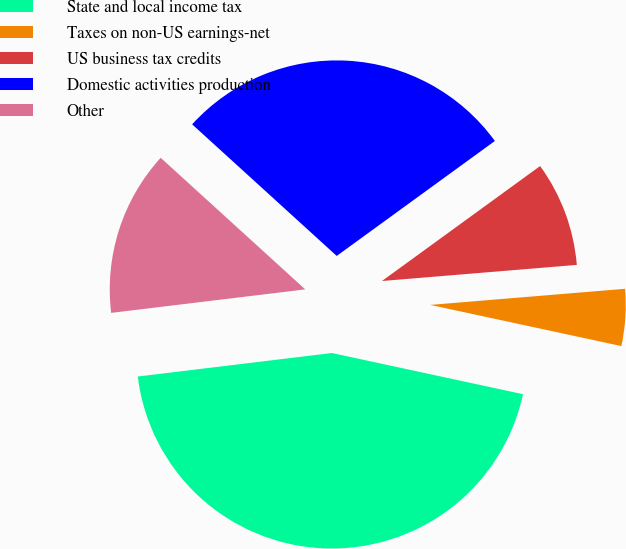Convert chart to OTSL. <chart><loc_0><loc_0><loc_500><loc_500><pie_chart><fcel>State and local income tax<fcel>Taxes on non-US earnings-net<fcel>US business tax credits<fcel>Domestic activities production<fcel>Other<nl><fcel>44.7%<fcel>4.69%<fcel>8.69%<fcel>28.24%<fcel>13.67%<nl></chart> 